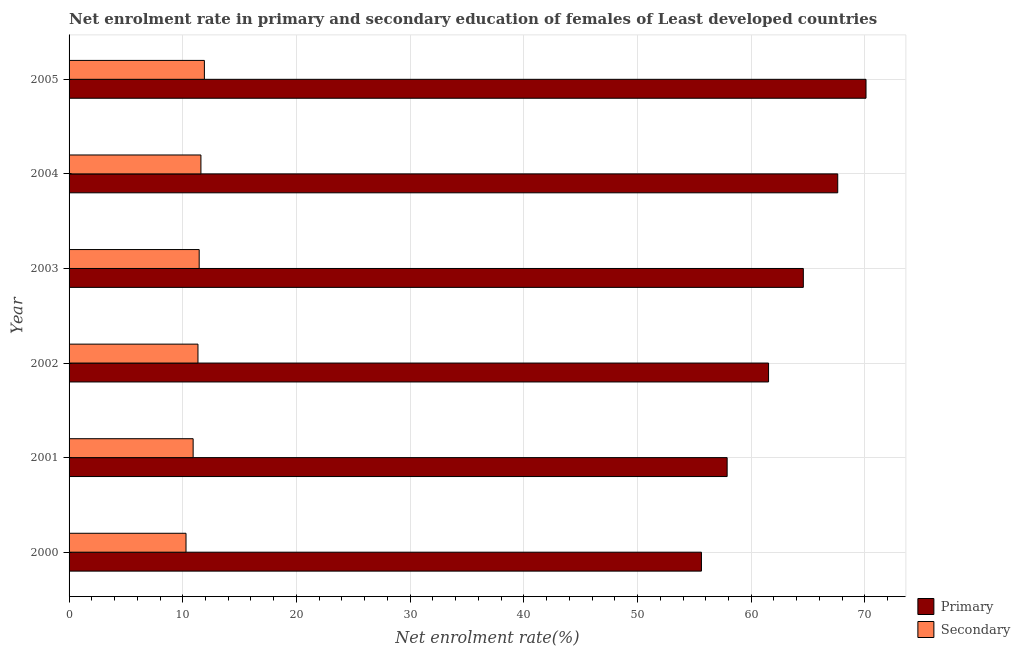How many different coloured bars are there?
Your answer should be very brief. 2. How many groups of bars are there?
Your answer should be very brief. 6. Are the number of bars per tick equal to the number of legend labels?
Offer a terse response. Yes. How many bars are there on the 6th tick from the top?
Your response must be concise. 2. What is the enrollment rate in secondary education in 2001?
Keep it short and to the point. 10.91. Across all years, what is the maximum enrollment rate in secondary education?
Offer a terse response. 11.9. Across all years, what is the minimum enrollment rate in secondary education?
Provide a succinct answer. 10.29. In which year was the enrollment rate in secondary education maximum?
Your response must be concise. 2005. In which year was the enrollment rate in primary education minimum?
Keep it short and to the point. 2000. What is the total enrollment rate in primary education in the graph?
Offer a terse response. 377.32. What is the difference between the enrollment rate in primary education in 2002 and that in 2005?
Ensure brevity in your answer.  -8.57. What is the difference between the enrollment rate in secondary education in 2000 and the enrollment rate in primary education in 2001?
Ensure brevity in your answer.  -47.6. What is the average enrollment rate in secondary education per year?
Your answer should be compact. 11.25. In the year 2005, what is the difference between the enrollment rate in primary education and enrollment rate in secondary education?
Keep it short and to the point. 58.2. In how many years, is the enrollment rate in primary education greater than 42 %?
Your response must be concise. 6. What is the ratio of the enrollment rate in primary education in 2000 to that in 2001?
Your answer should be compact. 0.96. What is the difference between the highest and the second highest enrollment rate in secondary education?
Provide a succinct answer. 0.3. What is the difference between the highest and the lowest enrollment rate in primary education?
Offer a terse response. 14.48. Is the sum of the enrollment rate in secondary education in 2001 and 2005 greater than the maximum enrollment rate in primary education across all years?
Make the answer very short. No. What does the 1st bar from the top in 2000 represents?
Your answer should be compact. Secondary. What does the 1st bar from the bottom in 2004 represents?
Provide a succinct answer. Primary. How many bars are there?
Make the answer very short. 12. Are all the bars in the graph horizontal?
Make the answer very short. Yes. How many years are there in the graph?
Your response must be concise. 6. What is the difference between two consecutive major ticks on the X-axis?
Keep it short and to the point. 10. Does the graph contain any zero values?
Provide a short and direct response. No. Does the graph contain grids?
Provide a short and direct response. Yes. How many legend labels are there?
Your answer should be compact. 2. What is the title of the graph?
Ensure brevity in your answer.  Net enrolment rate in primary and secondary education of females of Least developed countries. What is the label or title of the X-axis?
Provide a short and direct response. Net enrolment rate(%). What is the Net enrolment rate(%) in Primary in 2000?
Ensure brevity in your answer.  55.62. What is the Net enrolment rate(%) in Secondary in 2000?
Your answer should be compact. 10.29. What is the Net enrolment rate(%) of Primary in 2001?
Give a very brief answer. 57.88. What is the Net enrolment rate(%) of Secondary in 2001?
Your answer should be compact. 10.91. What is the Net enrolment rate(%) in Primary in 2002?
Your answer should be very brief. 61.53. What is the Net enrolment rate(%) in Secondary in 2002?
Keep it short and to the point. 11.34. What is the Net enrolment rate(%) in Primary in 2003?
Offer a terse response. 64.58. What is the Net enrolment rate(%) of Secondary in 2003?
Your answer should be very brief. 11.45. What is the Net enrolment rate(%) in Primary in 2004?
Provide a short and direct response. 67.61. What is the Net enrolment rate(%) in Secondary in 2004?
Give a very brief answer. 11.6. What is the Net enrolment rate(%) of Primary in 2005?
Offer a terse response. 70.1. What is the Net enrolment rate(%) of Secondary in 2005?
Provide a succinct answer. 11.9. Across all years, what is the maximum Net enrolment rate(%) in Primary?
Make the answer very short. 70.1. Across all years, what is the maximum Net enrolment rate(%) of Secondary?
Ensure brevity in your answer.  11.9. Across all years, what is the minimum Net enrolment rate(%) of Primary?
Your response must be concise. 55.62. Across all years, what is the minimum Net enrolment rate(%) in Secondary?
Offer a terse response. 10.29. What is the total Net enrolment rate(%) of Primary in the graph?
Your answer should be compact. 377.32. What is the total Net enrolment rate(%) in Secondary in the graph?
Provide a short and direct response. 67.48. What is the difference between the Net enrolment rate(%) in Primary in 2000 and that in 2001?
Provide a short and direct response. -2.26. What is the difference between the Net enrolment rate(%) of Secondary in 2000 and that in 2001?
Provide a succinct answer. -0.63. What is the difference between the Net enrolment rate(%) of Primary in 2000 and that in 2002?
Provide a short and direct response. -5.9. What is the difference between the Net enrolment rate(%) in Secondary in 2000 and that in 2002?
Provide a succinct answer. -1.05. What is the difference between the Net enrolment rate(%) of Primary in 2000 and that in 2003?
Give a very brief answer. -8.96. What is the difference between the Net enrolment rate(%) in Secondary in 2000 and that in 2003?
Your answer should be very brief. -1.16. What is the difference between the Net enrolment rate(%) in Primary in 2000 and that in 2004?
Your answer should be compact. -11.99. What is the difference between the Net enrolment rate(%) of Secondary in 2000 and that in 2004?
Your answer should be very brief. -1.31. What is the difference between the Net enrolment rate(%) in Primary in 2000 and that in 2005?
Your answer should be very brief. -14.48. What is the difference between the Net enrolment rate(%) in Secondary in 2000 and that in 2005?
Keep it short and to the point. -1.62. What is the difference between the Net enrolment rate(%) of Primary in 2001 and that in 2002?
Your answer should be compact. -3.64. What is the difference between the Net enrolment rate(%) of Secondary in 2001 and that in 2002?
Your answer should be very brief. -0.42. What is the difference between the Net enrolment rate(%) in Primary in 2001 and that in 2003?
Your answer should be compact. -6.7. What is the difference between the Net enrolment rate(%) in Secondary in 2001 and that in 2003?
Your answer should be compact. -0.53. What is the difference between the Net enrolment rate(%) in Primary in 2001 and that in 2004?
Offer a very short reply. -9.73. What is the difference between the Net enrolment rate(%) of Secondary in 2001 and that in 2004?
Keep it short and to the point. -0.68. What is the difference between the Net enrolment rate(%) of Primary in 2001 and that in 2005?
Provide a succinct answer. -12.22. What is the difference between the Net enrolment rate(%) of Secondary in 2001 and that in 2005?
Offer a very short reply. -0.99. What is the difference between the Net enrolment rate(%) in Primary in 2002 and that in 2003?
Your answer should be compact. -3.06. What is the difference between the Net enrolment rate(%) of Secondary in 2002 and that in 2003?
Your response must be concise. -0.11. What is the difference between the Net enrolment rate(%) in Primary in 2002 and that in 2004?
Ensure brevity in your answer.  -6.08. What is the difference between the Net enrolment rate(%) of Secondary in 2002 and that in 2004?
Your answer should be very brief. -0.26. What is the difference between the Net enrolment rate(%) of Primary in 2002 and that in 2005?
Your answer should be very brief. -8.57. What is the difference between the Net enrolment rate(%) in Secondary in 2002 and that in 2005?
Provide a short and direct response. -0.56. What is the difference between the Net enrolment rate(%) in Primary in 2003 and that in 2004?
Keep it short and to the point. -3.03. What is the difference between the Net enrolment rate(%) of Secondary in 2003 and that in 2004?
Provide a succinct answer. -0.15. What is the difference between the Net enrolment rate(%) in Primary in 2003 and that in 2005?
Offer a very short reply. -5.51. What is the difference between the Net enrolment rate(%) in Secondary in 2003 and that in 2005?
Make the answer very short. -0.46. What is the difference between the Net enrolment rate(%) of Primary in 2004 and that in 2005?
Your answer should be very brief. -2.49. What is the difference between the Net enrolment rate(%) in Secondary in 2004 and that in 2005?
Ensure brevity in your answer.  -0.3. What is the difference between the Net enrolment rate(%) in Primary in 2000 and the Net enrolment rate(%) in Secondary in 2001?
Offer a terse response. 44.71. What is the difference between the Net enrolment rate(%) in Primary in 2000 and the Net enrolment rate(%) in Secondary in 2002?
Provide a succinct answer. 44.28. What is the difference between the Net enrolment rate(%) of Primary in 2000 and the Net enrolment rate(%) of Secondary in 2003?
Make the answer very short. 44.18. What is the difference between the Net enrolment rate(%) of Primary in 2000 and the Net enrolment rate(%) of Secondary in 2004?
Ensure brevity in your answer.  44.02. What is the difference between the Net enrolment rate(%) of Primary in 2000 and the Net enrolment rate(%) of Secondary in 2005?
Offer a very short reply. 43.72. What is the difference between the Net enrolment rate(%) of Primary in 2001 and the Net enrolment rate(%) of Secondary in 2002?
Make the answer very short. 46.55. What is the difference between the Net enrolment rate(%) of Primary in 2001 and the Net enrolment rate(%) of Secondary in 2003?
Keep it short and to the point. 46.44. What is the difference between the Net enrolment rate(%) in Primary in 2001 and the Net enrolment rate(%) in Secondary in 2004?
Ensure brevity in your answer.  46.29. What is the difference between the Net enrolment rate(%) in Primary in 2001 and the Net enrolment rate(%) in Secondary in 2005?
Make the answer very short. 45.98. What is the difference between the Net enrolment rate(%) of Primary in 2002 and the Net enrolment rate(%) of Secondary in 2003?
Provide a succinct answer. 50.08. What is the difference between the Net enrolment rate(%) in Primary in 2002 and the Net enrolment rate(%) in Secondary in 2004?
Ensure brevity in your answer.  49.93. What is the difference between the Net enrolment rate(%) of Primary in 2002 and the Net enrolment rate(%) of Secondary in 2005?
Offer a terse response. 49.62. What is the difference between the Net enrolment rate(%) in Primary in 2003 and the Net enrolment rate(%) in Secondary in 2004?
Your answer should be compact. 52.99. What is the difference between the Net enrolment rate(%) of Primary in 2003 and the Net enrolment rate(%) of Secondary in 2005?
Your answer should be compact. 52.68. What is the difference between the Net enrolment rate(%) in Primary in 2004 and the Net enrolment rate(%) in Secondary in 2005?
Offer a very short reply. 55.71. What is the average Net enrolment rate(%) of Primary per year?
Your answer should be very brief. 62.89. What is the average Net enrolment rate(%) of Secondary per year?
Keep it short and to the point. 11.25. In the year 2000, what is the difference between the Net enrolment rate(%) of Primary and Net enrolment rate(%) of Secondary?
Give a very brief answer. 45.34. In the year 2001, what is the difference between the Net enrolment rate(%) of Primary and Net enrolment rate(%) of Secondary?
Make the answer very short. 46.97. In the year 2002, what is the difference between the Net enrolment rate(%) of Primary and Net enrolment rate(%) of Secondary?
Make the answer very short. 50.19. In the year 2003, what is the difference between the Net enrolment rate(%) in Primary and Net enrolment rate(%) in Secondary?
Your answer should be compact. 53.14. In the year 2004, what is the difference between the Net enrolment rate(%) in Primary and Net enrolment rate(%) in Secondary?
Provide a short and direct response. 56.01. In the year 2005, what is the difference between the Net enrolment rate(%) of Primary and Net enrolment rate(%) of Secondary?
Ensure brevity in your answer.  58.2. What is the ratio of the Net enrolment rate(%) of Primary in 2000 to that in 2001?
Provide a succinct answer. 0.96. What is the ratio of the Net enrolment rate(%) of Secondary in 2000 to that in 2001?
Your answer should be compact. 0.94. What is the ratio of the Net enrolment rate(%) in Primary in 2000 to that in 2002?
Ensure brevity in your answer.  0.9. What is the ratio of the Net enrolment rate(%) of Secondary in 2000 to that in 2002?
Offer a very short reply. 0.91. What is the ratio of the Net enrolment rate(%) in Primary in 2000 to that in 2003?
Your response must be concise. 0.86. What is the ratio of the Net enrolment rate(%) of Secondary in 2000 to that in 2003?
Ensure brevity in your answer.  0.9. What is the ratio of the Net enrolment rate(%) in Primary in 2000 to that in 2004?
Your response must be concise. 0.82. What is the ratio of the Net enrolment rate(%) of Secondary in 2000 to that in 2004?
Your answer should be compact. 0.89. What is the ratio of the Net enrolment rate(%) in Primary in 2000 to that in 2005?
Provide a succinct answer. 0.79. What is the ratio of the Net enrolment rate(%) in Secondary in 2000 to that in 2005?
Your answer should be compact. 0.86. What is the ratio of the Net enrolment rate(%) in Primary in 2001 to that in 2002?
Offer a very short reply. 0.94. What is the ratio of the Net enrolment rate(%) of Secondary in 2001 to that in 2002?
Offer a very short reply. 0.96. What is the ratio of the Net enrolment rate(%) in Primary in 2001 to that in 2003?
Give a very brief answer. 0.9. What is the ratio of the Net enrolment rate(%) of Secondary in 2001 to that in 2003?
Ensure brevity in your answer.  0.95. What is the ratio of the Net enrolment rate(%) of Primary in 2001 to that in 2004?
Offer a very short reply. 0.86. What is the ratio of the Net enrolment rate(%) of Secondary in 2001 to that in 2004?
Offer a terse response. 0.94. What is the ratio of the Net enrolment rate(%) in Primary in 2001 to that in 2005?
Your answer should be compact. 0.83. What is the ratio of the Net enrolment rate(%) in Secondary in 2001 to that in 2005?
Ensure brevity in your answer.  0.92. What is the ratio of the Net enrolment rate(%) in Primary in 2002 to that in 2003?
Give a very brief answer. 0.95. What is the ratio of the Net enrolment rate(%) in Secondary in 2002 to that in 2003?
Give a very brief answer. 0.99. What is the ratio of the Net enrolment rate(%) of Primary in 2002 to that in 2004?
Your answer should be very brief. 0.91. What is the ratio of the Net enrolment rate(%) of Secondary in 2002 to that in 2004?
Your answer should be very brief. 0.98. What is the ratio of the Net enrolment rate(%) in Primary in 2002 to that in 2005?
Give a very brief answer. 0.88. What is the ratio of the Net enrolment rate(%) in Secondary in 2002 to that in 2005?
Provide a short and direct response. 0.95. What is the ratio of the Net enrolment rate(%) of Primary in 2003 to that in 2004?
Keep it short and to the point. 0.96. What is the ratio of the Net enrolment rate(%) of Secondary in 2003 to that in 2004?
Give a very brief answer. 0.99. What is the ratio of the Net enrolment rate(%) of Primary in 2003 to that in 2005?
Provide a succinct answer. 0.92. What is the ratio of the Net enrolment rate(%) of Secondary in 2003 to that in 2005?
Provide a succinct answer. 0.96. What is the ratio of the Net enrolment rate(%) of Primary in 2004 to that in 2005?
Your answer should be very brief. 0.96. What is the ratio of the Net enrolment rate(%) in Secondary in 2004 to that in 2005?
Provide a short and direct response. 0.97. What is the difference between the highest and the second highest Net enrolment rate(%) in Primary?
Offer a terse response. 2.49. What is the difference between the highest and the second highest Net enrolment rate(%) in Secondary?
Ensure brevity in your answer.  0.3. What is the difference between the highest and the lowest Net enrolment rate(%) of Primary?
Keep it short and to the point. 14.48. What is the difference between the highest and the lowest Net enrolment rate(%) in Secondary?
Your response must be concise. 1.62. 